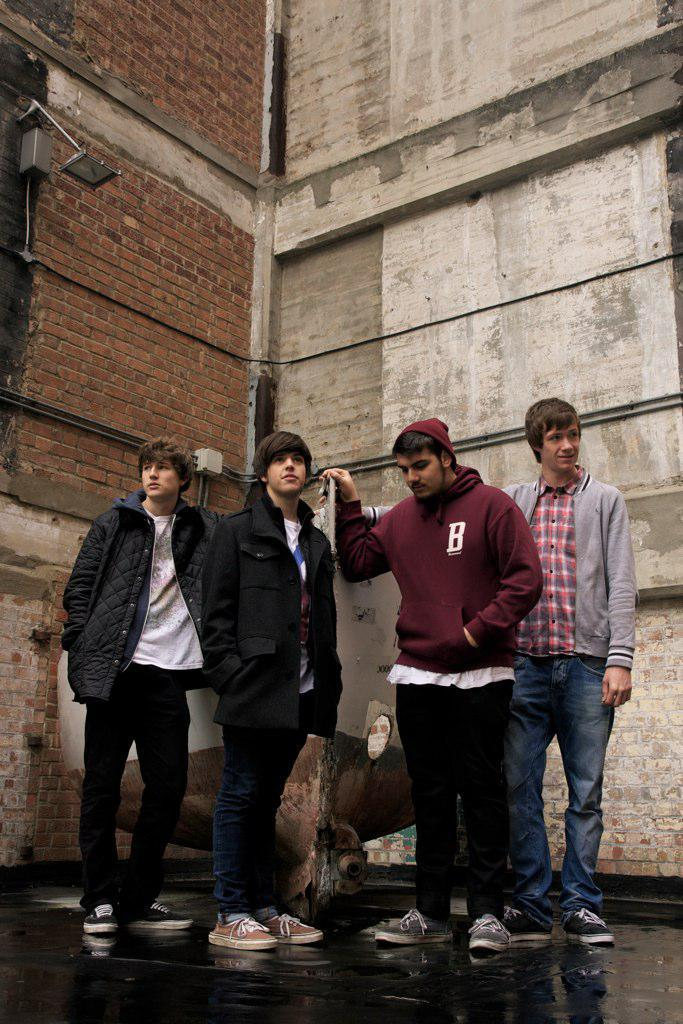How many people are present in the image? There are four persons standing in the image. What can be seen in the background of the image? There is a building and a light source in the background of the image. Can you describe the unspecified object in the background? Unfortunately, the facts provided do not give any details about the unspecified object in the background. What type of collar is the grandmother wearing in the image? There is no grandmother or collar present in the image. 